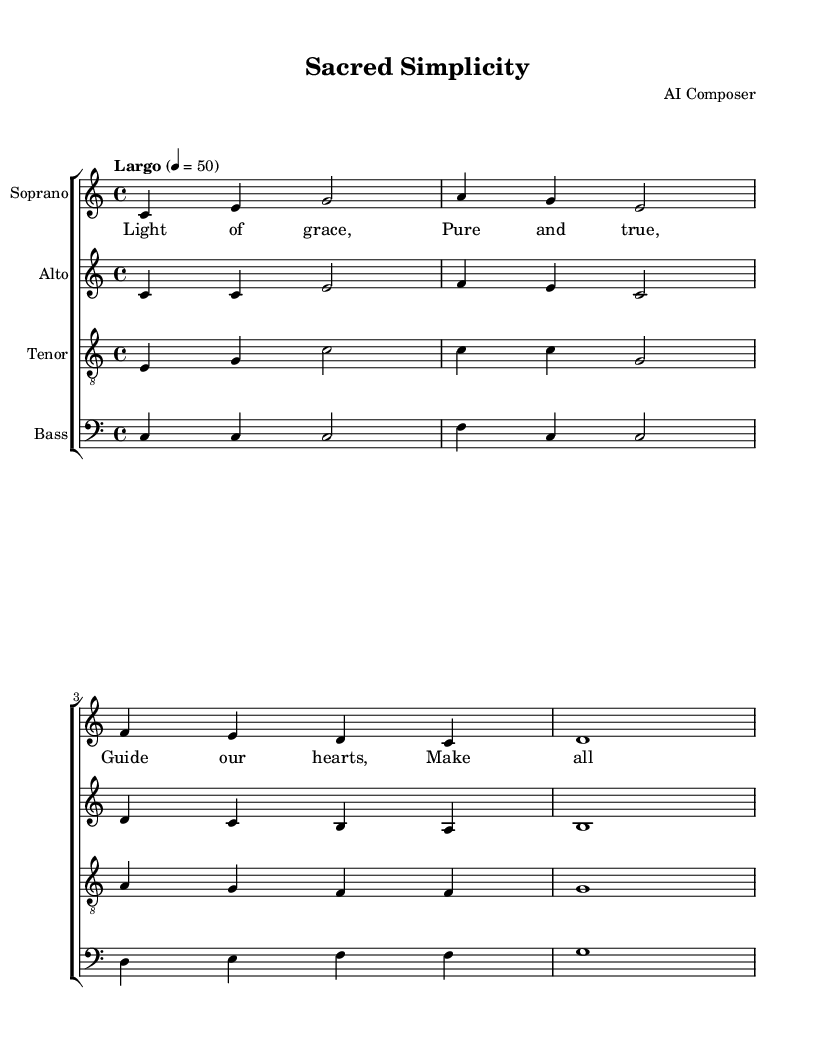What is the key signature of this music? The key signature is indicated at the beginning of the score with a "C", and it has no sharps or flats, which defines it as C major.
Answer: C major What is the time signature of this piece? The time signature is shown as "4/4" at the beginning of the score, indicating four beats per measure.
Answer: 4/4 What is the tempo marking for this composition? The tempo marking appears as "Largo" with a metronome marking of "4 = 50" indicating a slow tempo.
Answer: Largo How many measures are in the soprano part? By counting the distinct groups of notes separated by the bar lines in the soprano part, we find there are four measures represented.
Answer: 4 What is the main theme of the lyrics? The lyrics focus on themes of guidance and renewal, as indicated by phrases like "Guide our hearts" and "Make all things new."
Answer: Guidance and renewal Which voice has the highest pitch range in this score? By observing the notated pitches in each voice part, the soprano part contains the highest notes, indicating it has the highest pitch range among the sections.
Answer: Soprano What is the significance of the word "grace" in the context of this piece? The word "grace" is central to the spiritual theme of the lyrics, emphasizing a desire for divine intervention and purity, which is typical in religious compositions.
Answer: Divine intervention 